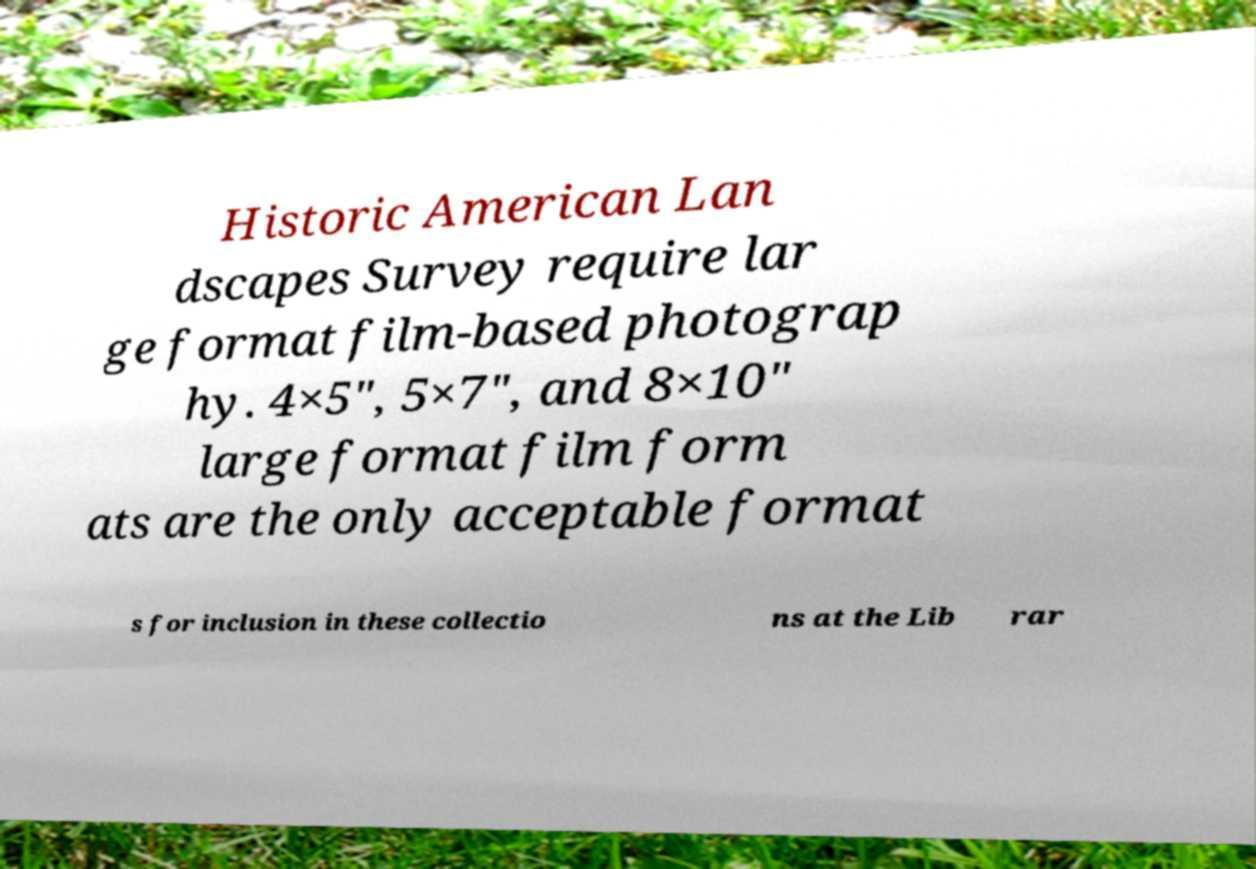I need the written content from this picture converted into text. Can you do that? Historic American Lan dscapes Survey require lar ge format film-based photograp hy. 4×5″, 5×7″, and 8×10″ large format film form ats are the only acceptable format s for inclusion in these collectio ns at the Lib rar 